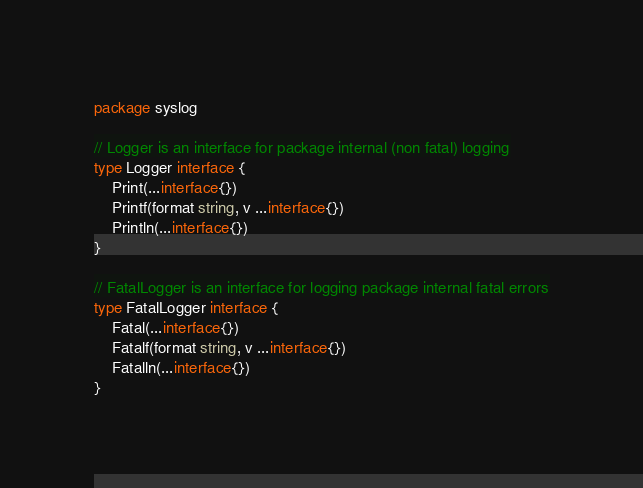<code> <loc_0><loc_0><loc_500><loc_500><_Go_>package syslog

// Logger is an interface for package internal (non fatal) logging
type Logger interface {
	Print(...interface{})
	Printf(format string, v ...interface{})
	Println(...interface{})
}

// FatalLogger is an interface for logging package internal fatal errors
type FatalLogger interface {
	Fatal(...interface{})
	Fatalf(format string, v ...interface{})
	Fatalln(...interface{})
}
</code> 